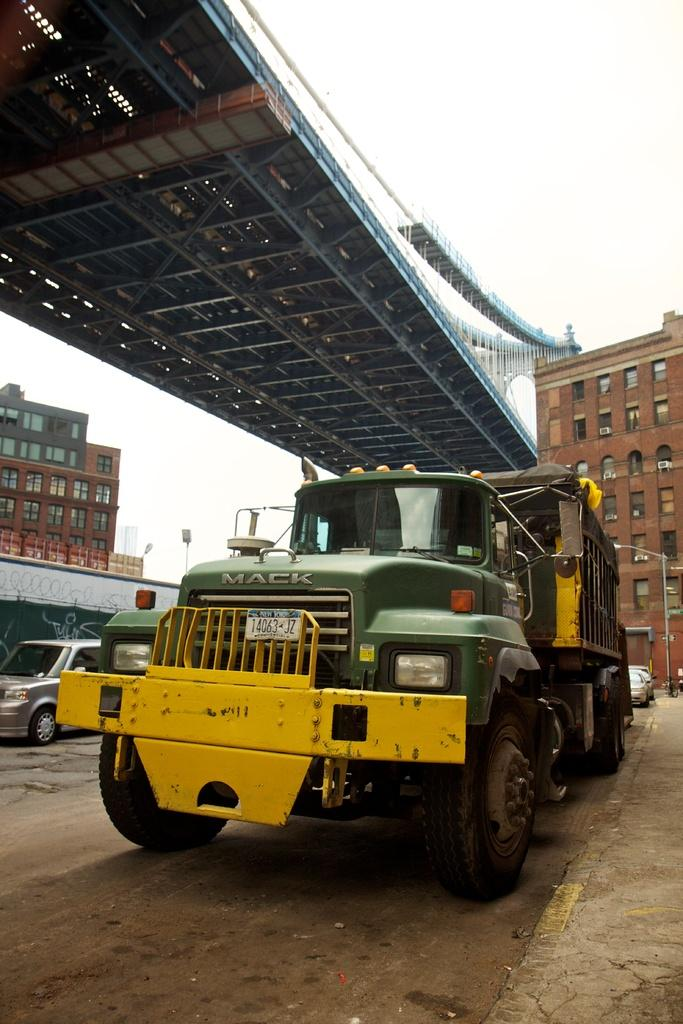<image>
Create a compact narrative representing the image presented. A Mack truck with a New York liscense tag that reads 14063 JZ. 